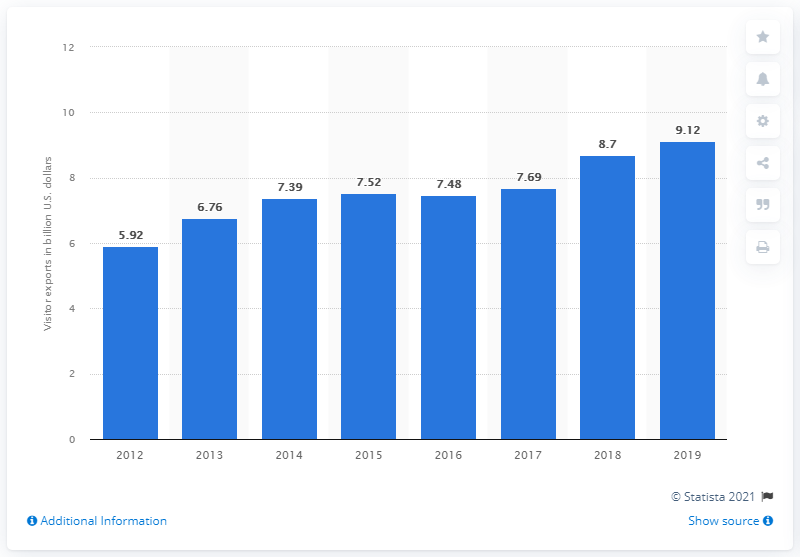Specify some key components in this picture. In 2018, Vietnam's visitor exports were 8.7 million. 